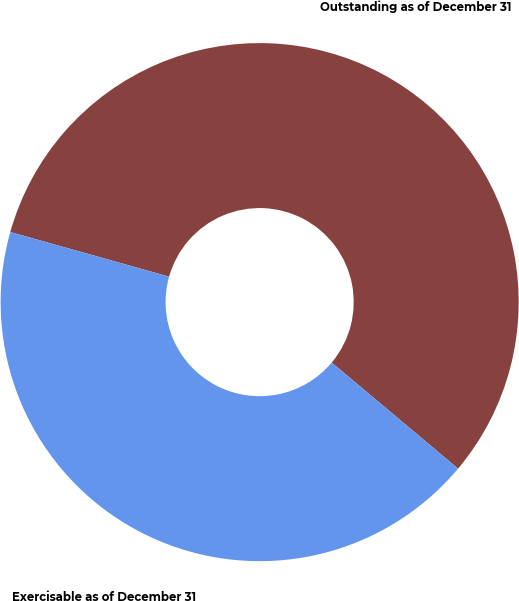Convert chart to OTSL. <chart><loc_0><loc_0><loc_500><loc_500><pie_chart><fcel>Outstanding as of December 31<fcel>Exercisable as of December 31<nl><fcel>56.75%<fcel>43.25%<nl></chart> 